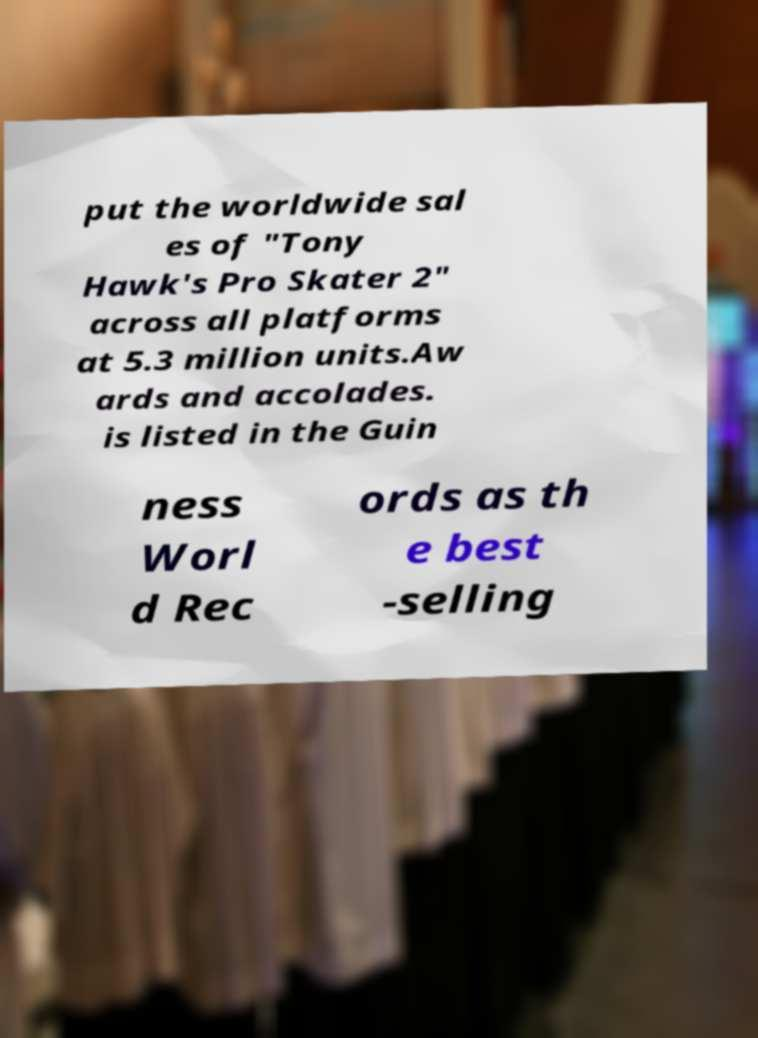Please read and relay the text visible in this image. What does it say? put the worldwide sal es of "Tony Hawk's Pro Skater 2" across all platforms at 5.3 million units.Aw ards and accolades. is listed in the Guin ness Worl d Rec ords as th e best -selling 